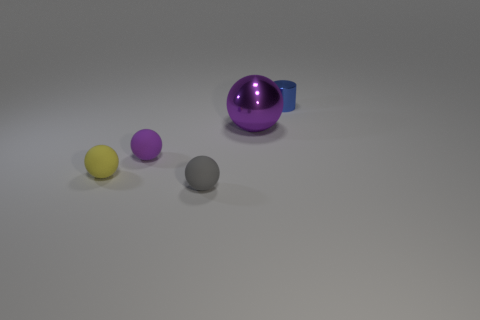There is a tiny thing that is the same color as the big shiny ball; what material is it?
Ensure brevity in your answer.  Rubber. The metallic object that is the same shape as the tiny yellow matte thing is what color?
Ensure brevity in your answer.  Purple. There is a ball that is in front of the tiny purple ball and behind the gray ball; what is its size?
Ensure brevity in your answer.  Small. There is a purple object in front of the large purple ball; is it the same shape as the small thing that is in front of the small yellow ball?
Give a very brief answer. Yes. What is the shape of the tiny matte thing that is the same color as the shiny ball?
Make the answer very short. Sphere. What number of brown cylinders have the same material as the tiny yellow sphere?
Provide a succinct answer. 0. There is a thing that is behind the purple matte ball and to the left of the blue object; what is its shape?
Offer a terse response. Sphere. Do the thing in front of the yellow matte ball and the small yellow thing have the same material?
Offer a terse response. Yes. There is a shiny object that is the same size as the purple matte object; what color is it?
Your response must be concise. Blue. Is there a tiny ball that has the same color as the large metal thing?
Keep it short and to the point. Yes. 